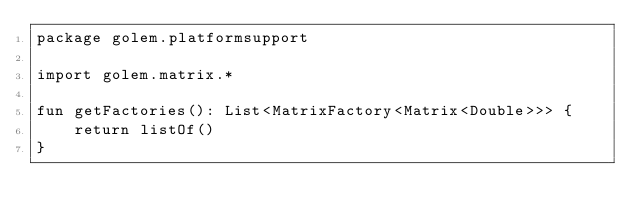Convert code to text. <code><loc_0><loc_0><loc_500><loc_500><_Kotlin_>package golem.platformsupport

import golem.matrix.*

fun getFactories(): List<MatrixFactory<Matrix<Double>>> {
    return listOf()
}
</code> 